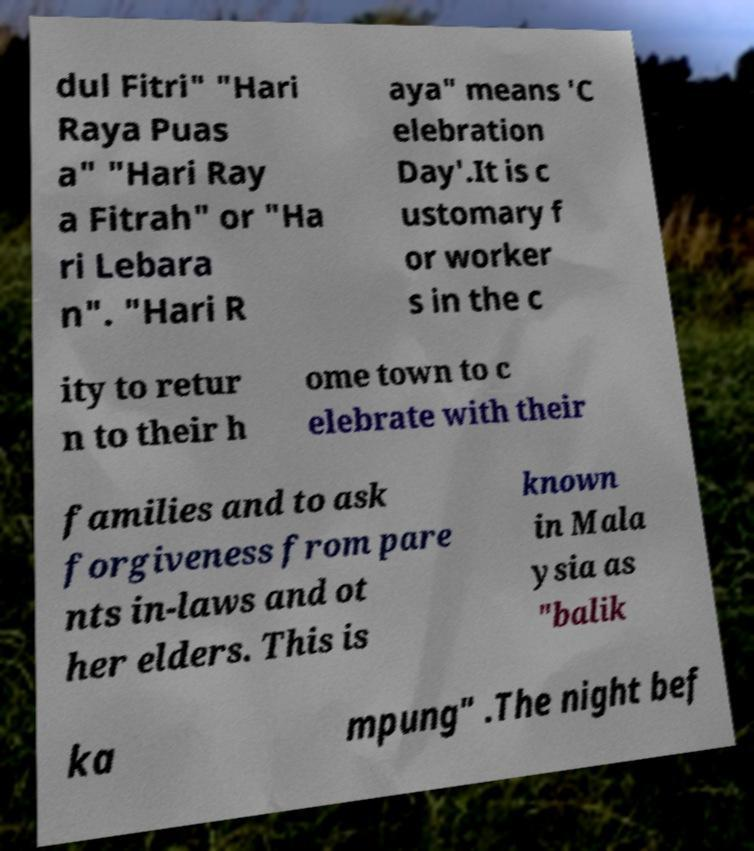Can you read and provide the text displayed in the image?This photo seems to have some interesting text. Can you extract and type it out for me? dul Fitri" "Hari Raya Puas a" "Hari Ray a Fitrah" or "Ha ri Lebara n". "Hari R aya" means 'C elebration Day'.It is c ustomary f or worker s in the c ity to retur n to their h ome town to c elebrate with their families and to ask forgiveness from pare nts in-laws and ot her elders. This is known in Mala ysia as "balik ka mpung" .The night bef 